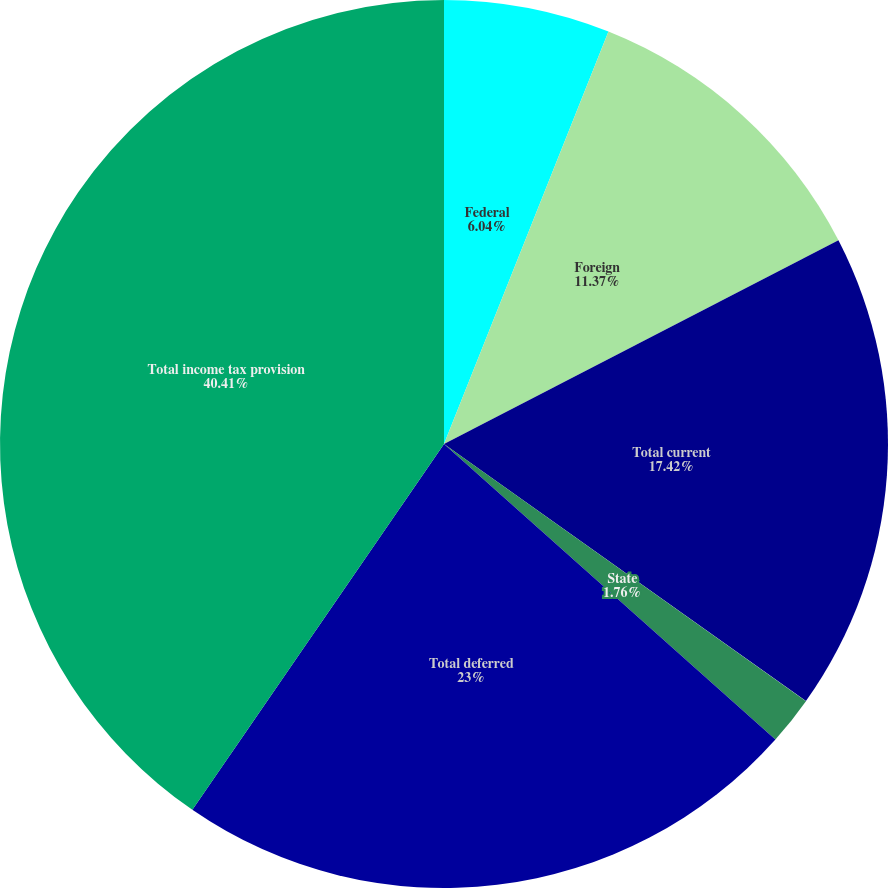Convert chart. <chart><loc_0><loc_0><loc_500><loc_500><pie_chart><fcel>Federal<fcel>Foreign<fcel>Total current<fcel>State<fcel>Total deferred<fcel>Total income tax provision<nl><fcel>6.04%<fcel>11.37%<fcel>17.42%<fcel>1.76%<fcel>23.0%<fcel>40.41%<nl></chart> 